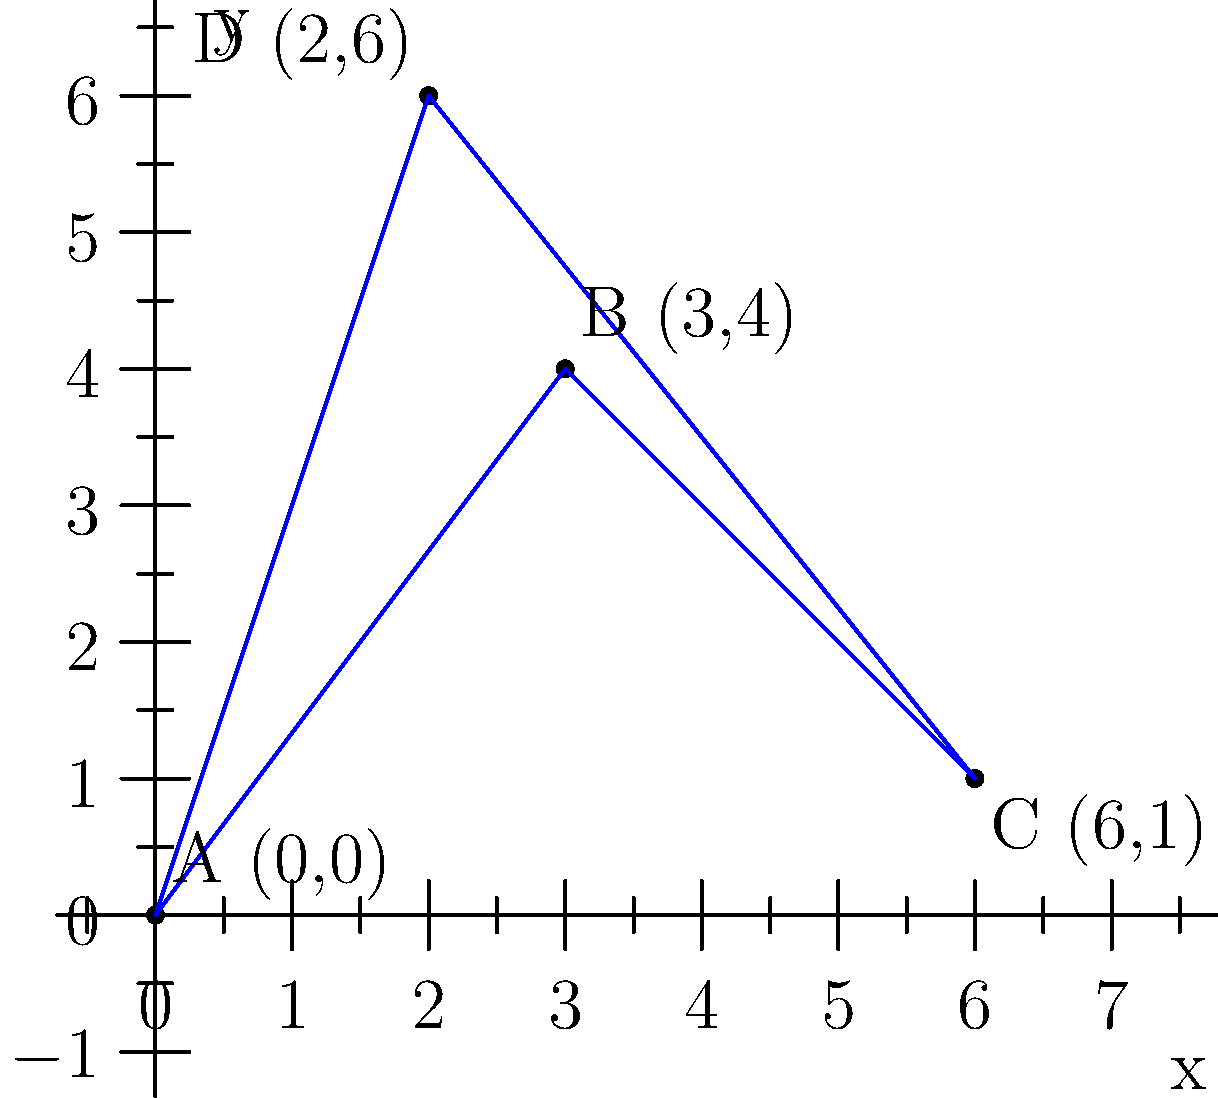As the postmaster general, you need to determine the most efficient route for a delivery truck visiting four locations: A(0,0), B(3,4), C(6,1), and D(2,6). Calculate the total distance traveled if the truck follows the path A → B → C → D → A. Round your answer to the nearest tenth of a unit. To solve this problem, we'll calculate the distance between each pair of consecutive points and sum them up:

1. Distance AB: 
   $\sqrt{(3-0)^2 + (4-0)^2} = \sqrt{9 + 16} = \sqrt{25} = 5$ units

2. Distance BC:
   $\sqrt{(6-3)^2 + (1-4)^2} = \sqrt{9 + (-3)^2} = \sqrt{18} \approx 4.24$ units

3. Distance CD:
   $\sqrt{(2-6)^2 + (6-1)^2} = \sqrt{(-4)^2 + 5^2} = \sqrt{16 + 25} = \sqrt{41} \approx 6.40$ units

4. Distance DA:
   $\sqrt{(0-2)^2 + (0-6)^2} = \sqrt{(-2)^2 + (-6)^2} = \sqrt{4 + 36} = \sqrt{40} \approx 6.32$ units

Total distance: $5 + 4.24 + 6.40 + 6.32 = 21.96$ units

Rounding to the nearest tenth: 22.0 units
Answer: 22.0 units 